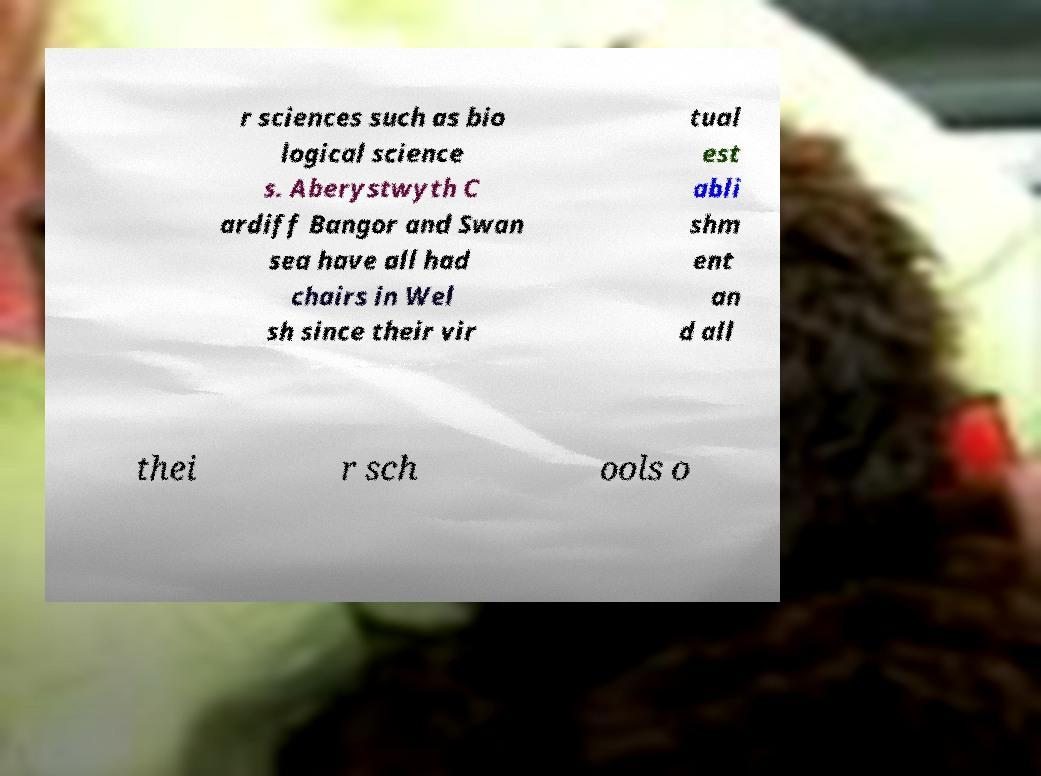Please read and relay the text visible in this image. What does it say? r sciences such as bio logical science s. Aberystwyth C ardiff Bangor and Swan sea have all had chairs in Wel sh since their vir tual est abli shm ent an d all thei r sch ools o 